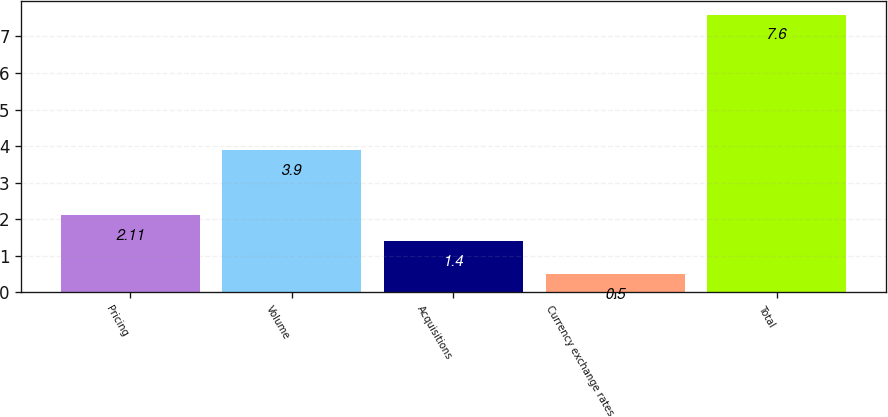Convert chart to OTSL. <chart><loc_0><loc_0><loc_500><loc_500><bar_chart><fcel>Pricing<fcel>Volume<fcel>Acquisitions<fcel>Currency exchange rates<fcel>Total<nl><fcel>2.11<fcel>3.9<fcel>1.4<fcel>0.5<fcel>7.6<nl></chart> 